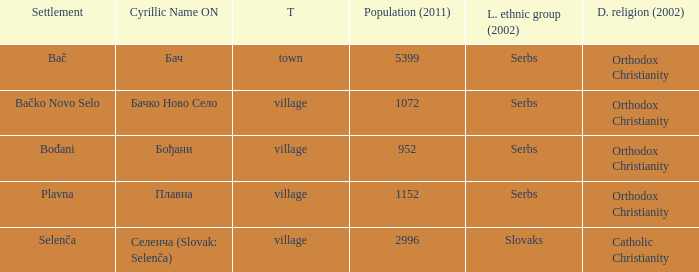What is the second way of writting плавна. Plavna. 